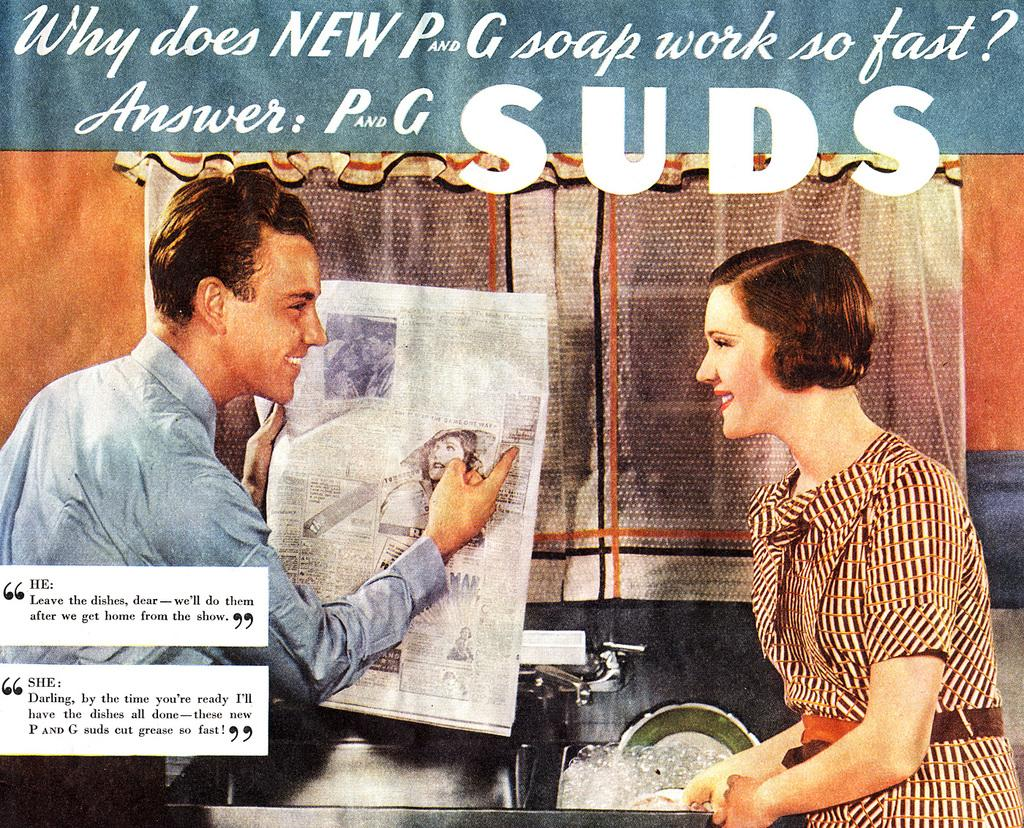How many people are in the image? There are two people in the image. What are the two people doing in the image? The two people are standing near a hand wash sink. What is one of the people holding in their hand? One of the people is holding a newspaper in their hand. What is the interaction between the two people in the image? The two people are looking at each other. What type of bread can be seen on the shoe of one of the people in the image? There is no bread or shoe visible in the image; it only shows two people standing near a hand wash sink. 